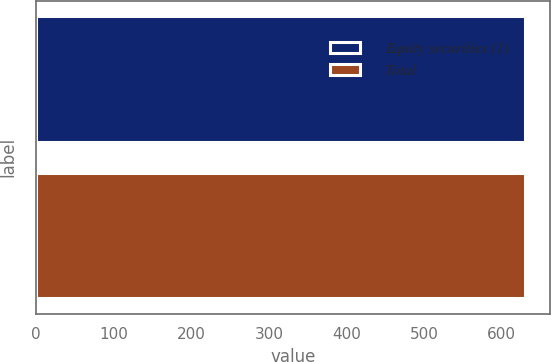Convert chart. <chart><loc_0><loc_0><loc_500><loc_500><bar_chart><fcel>Equity securities (1)<fcel>Total<nl><fcel>630.3<fcel>630.4<nl></chart> 